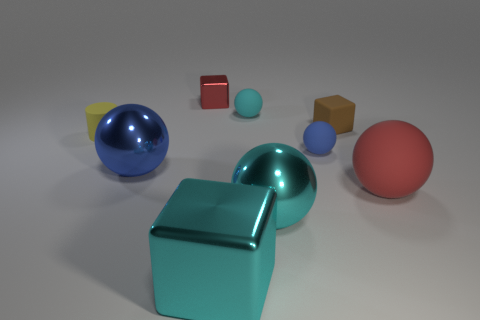Is the big rubber sphere the same color as the tiny metallic thing?
Give a very brief answer. Yes. What is the size of the matte ball that is the same color as the large metallic block?
Keep it short and to the point. Small. There is a small block that is on the left side of the large shiny cube; is its color the same as the metal thing on the right side of the small cyan sphere?
Give a very brief answer. No. What is the size of the rubber cylinder?
Make the answer very short. Small. How many big things are yellow cylinders or blue rubber spheres?
Offer a terse response. 0. What color is the cube that is the same size as the red rubber thing?
Offer a very short reply. Cyan. What number of other things are there of the same shape as the large red rubber thing?
Give a very brief answer. 4. Are there any other small spheres that have the same material as the tiny blue ball?
Offer a very short reply. Yes. Is the blue sphere to the left of the tiny red metallic block made of the same material as the big cyan object behind the large cyan shiny cube?
Your answer should be compact. Yes. How many cyan things are there?
Offer a very short reply. 3. 